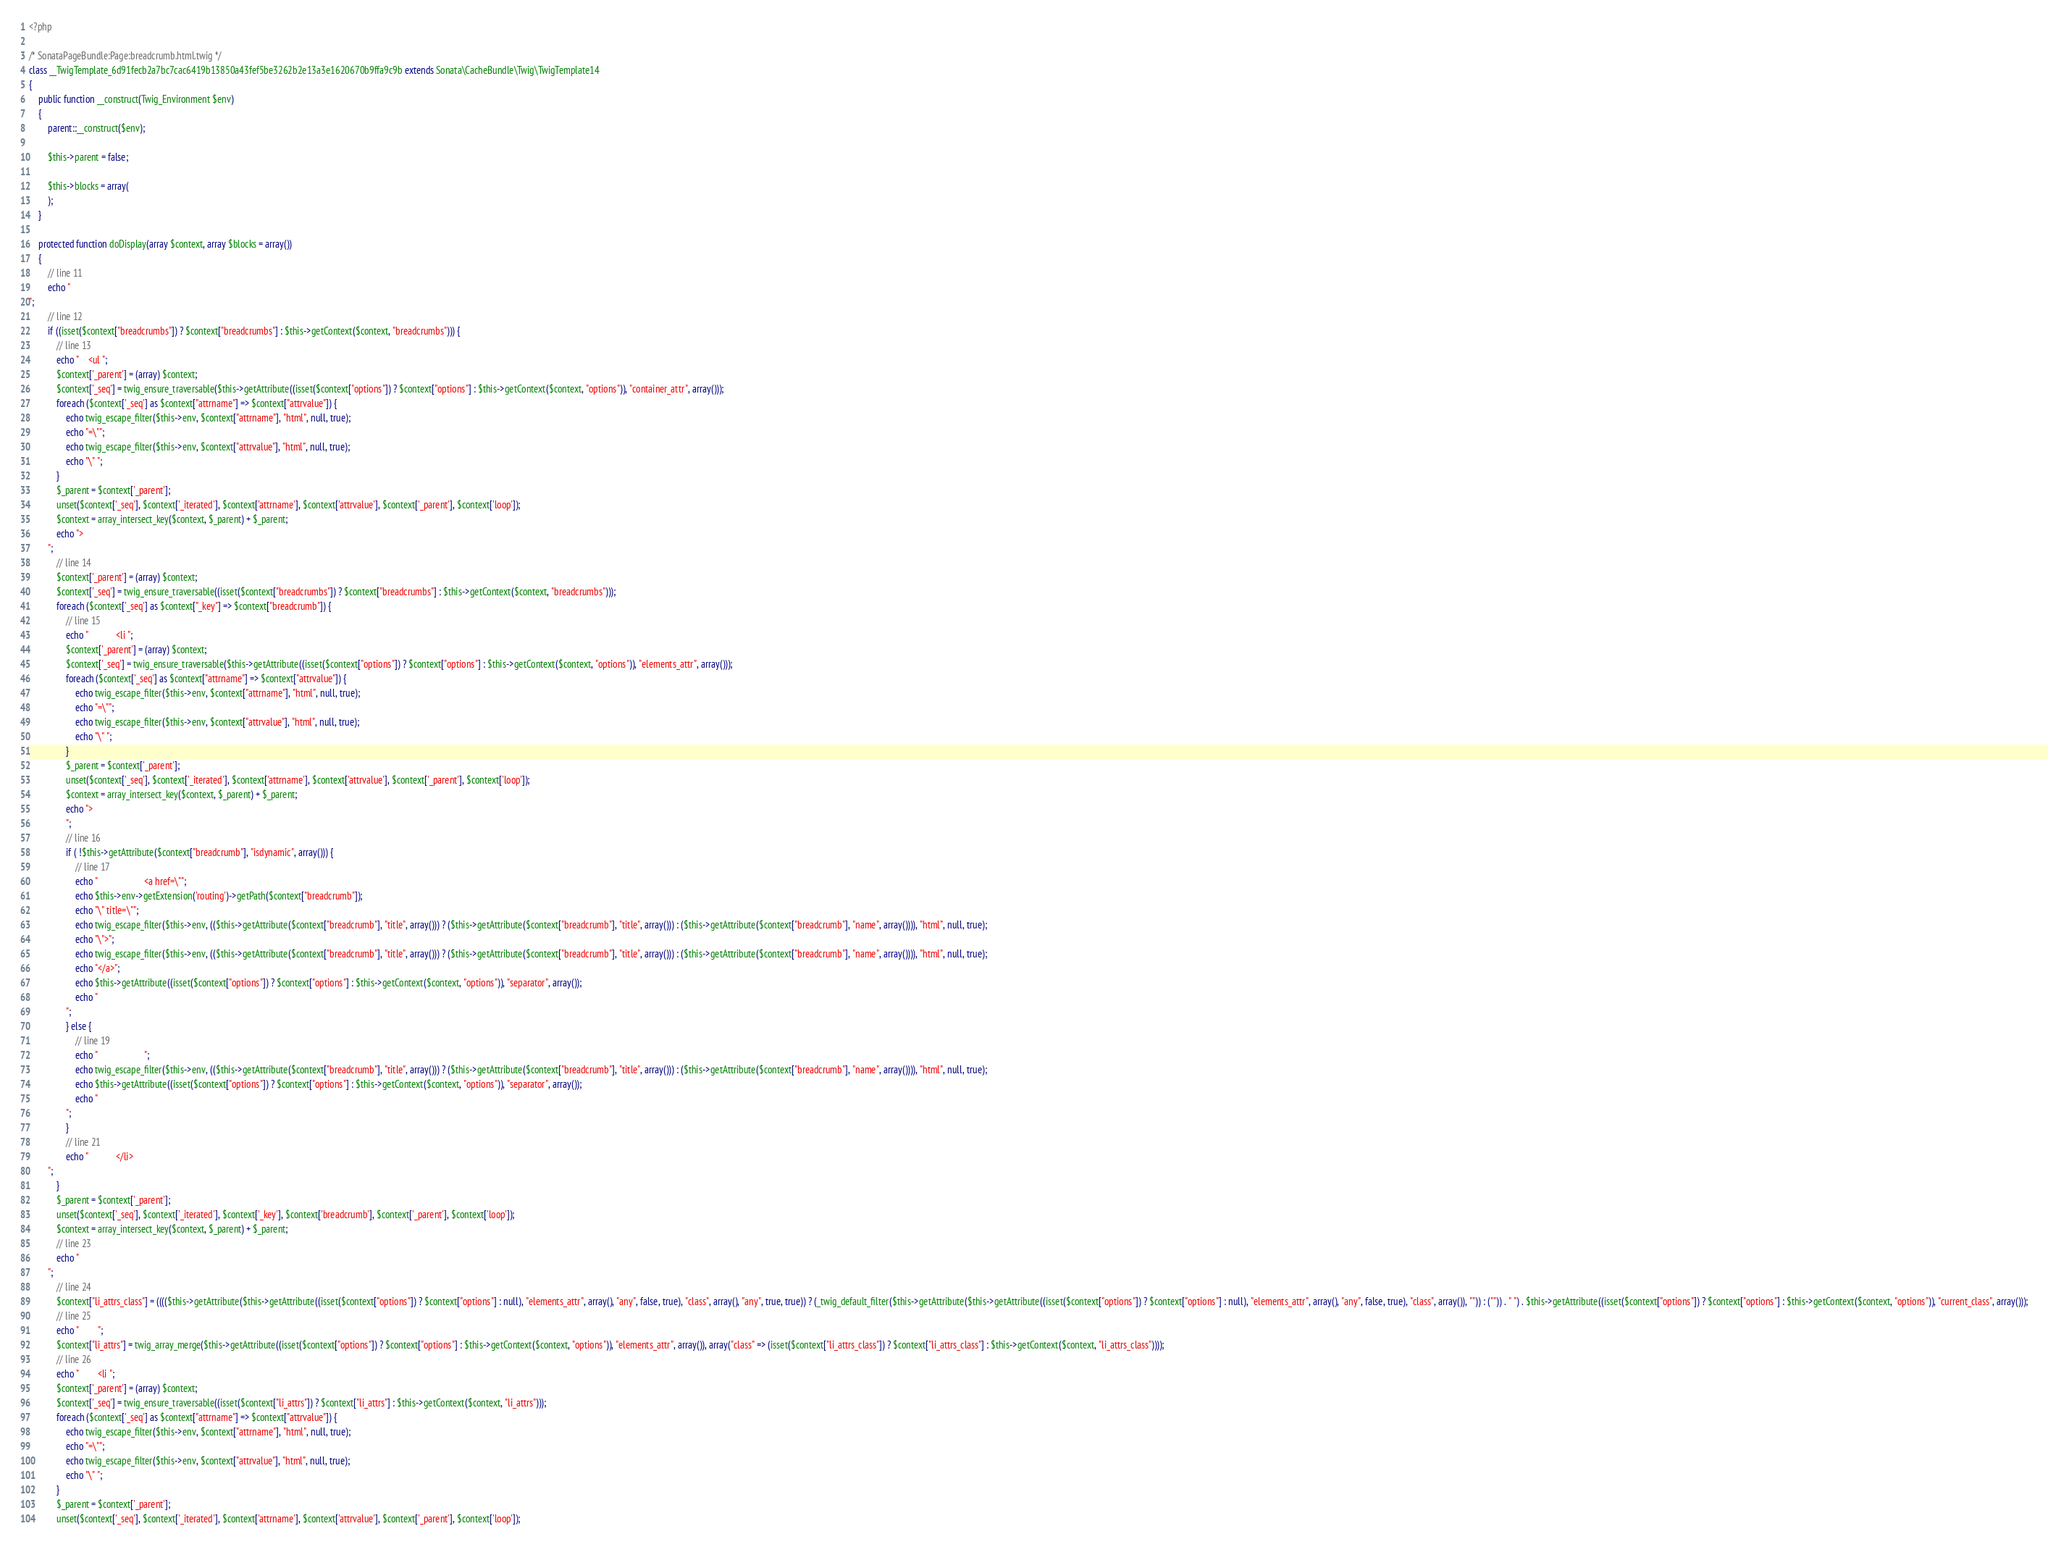Convert code to text. <code><loc_0><loc_0><loc_500><loc_500><_PHP_><?php

/* SonataPageBundle:Page:breadcrumb.html.twig */
class __TwigTemplate_6d91fecb2a7bc7cac6419b13850a43fef5be3262b2e13a3e1620670b9ffa9c9b extends Sonata\CacheBundle\Twig\TwigTemplate14
{
    public function __construct(Twig_Environment $env)
    {
        parent::__construct($env);

        $this->parent = false;

        $this->blocks = array(
        );
    }

    protected function doDisplay(array $context, array $blocks = array())
    {
        // line 11
        echo "
";
        // line 12
        if ((isset($context["breadcrumbs"]) ? $context["breadcrumbs"] : $this->getContext($context, "breadcrumbs"))) {
            // line 13
            echo "    <ul ";
            $context['_parent'] = (array) $context;
            $context['_seq'] = twig_ensure_traversable($this->getAttribute((isset($context["options"]) ? $context["options"] : $this->getContext($context, "options")), "container_attr", array()));
            foreach ($context['_seq'] as $context["attrname"] => $context["attrvalue"]) {
                echo twig_escape_filter($this->env, $context["attrname"], "html", null, true);
                echo "=\"";
                echo twig_escape_filter($this->env, $context["attrvalue"], "html", null, true);
                echo "\" ";
            }
            $_parent = $context['_parent'];
            unset($context['_seq'], $context['_iterated'], $context['attrname'], $context['attrvalue'], $context['_parent'], $context['loop']);
            $context = array_intersect_key($context, $_parent) + $_parent;
            echo ">
        ";
            // line 14
            $context['_parent'] = (array) $context;
            $context['_seq'] = twig_ensure_traversable((isset($context["breadcrumbs"]) ? $context["breadcrumbs"] : $this->getContext($context, "breadcrumbs")));
            foreach ($context['_seq'] as $context["_key"] => $context["breadcrumb"]) {
                // line 15
                echo "            <li ";
                $context['_parent'] = (array) $context;
                $context['_seq'] = twig_ensure_traversable($this->getAttribute((isset($context["options"]) ? $context["options"] : $this->getContext($context, "options")), "elements_attr", array()));
                foreach ($context['_seq'] as $context["attrname"] => $context["attrvalue"]) {
                    echo twig_escape_filter($this->env, $context["attrname"], "html", null, true);
                    echo "=\"";
                    echo twig_escape_filter($this->env, $context["attrvalue"], "html", null, true);
                    echo "\" ";
                }
                $_parent = $context['_parent'];
                unset($context['_seq'], $context['_iterated'], $context['attrname'], $context['attrvalue'], $context['_parent'], $context['loop']);
                $context = array_intersect_key($context, $_parent) + $_parent;
                echo ">
                ";
                // line 16
                if ( !$this->getAttribute($context["breadcrumb"], "isdynamic", array())) {
                    // line 17
                    echo "                    <a href=\"";
                    echo $this->env->getExtension('routing')->getPath($context["breadcrumb"]);
                    echo "\" title=\"";
                    echo twig_escape_filter($this->env, (($this->getAttribute($context["breadcrumb"], "title", array())) ? ($this->getAttribute($context["breadcrumb"], "title", array())) : ($this->getAttribute($context["breadcrumb"], "name", array()))), "html", null, true);
                    echo "\">";
                    echo twig_escape_filter($this->env, (($this->getAttribute($context["breadcrumb"], "title", array())) ? ($this->getAttribute($context["breadcrumb"], "title", array())) : ($this->getAttribute($context["breadcrumb"], "name", array()))), "html", null, true);
                    echo "</a>";
                    echo $this->getAttribute((isset($context["options"]) ? $context["options"] : $this->getContext($context, "options")), "separator", array());
                    echo "
                ";
                } else {
                    // line 19
                    echo "                    ";
                    echo twig_escape_filter($this->env, (($this->getAttribute($context["breadcrumb"], "title", array())) ? ($this->getAttribute($context["breadcrumb"], "title", array())) : ($this->getAttribute($context["breadcrumb"], "name", array()))), "html", null, true);
                    echo $this->getAttribute((isset($context["options"]) ? $context["options"] : $this->getContext($context, "options")), "separator", array());
                    echo "
                ";
                }
                // line 21
                echo "            </li>
        ";
            }
            $_parent = $context['_parent'];
            unset($context['_seq'], $context['_iterated'], $context['_key'], $context['breadcrumb'], $context['_parent'], $context['loop']);
            $context = array_intersect_key($context, $_parent) + $_parent;
            // line 23
            echo "
        ";
            // line 24
            $context["li_attrs_class"] = (((($this->getAttribute($this->getAttribute((isset($context["options"]) ? $context["options"] : null), "elements_attr", array(), "any", false, true), "class", array(), "any", true, true)) ? (_twig_default_filter($this->getAttribute($this->getAttribute((isset($context["options"]) ? $context["options"] : null), "elements_attr", array(), "any", false, true), "class", array()), "")) : ("")) . " ") . $this->getAttribute((isset($context["options"]) ? $context["options"] : $this->getContext($context, "options")), "current_class", array()));
            // line 25
            echo "        ";
            $context["li_attrs"] = twig_array_merge($this->getAttribute((isset($context["options"]) ? $context["options"] : $this->getContext($context, "options")), "elements_attr", array()), array("class" => (isset($context["li_attrs_class"]) ? $context["li_attrs_class"] : $this->getContext($context, "li_attrs_class"))));
            // line 26
            echo "        <li ";
            $context['_parent'] = (array) $context;
            $context['_seq'] = twig_ensure_traversable((isset($context["li_attrs"]) ? $context["li_attrs"] : $this->getContext($context, "li_attrs")));
            foreach ($context['_seq'] as $context["attrname"] => $context["attrvalue"]) {
                echo twig_escape_filter($this->env, $context["attrname"], "html", null, true);
                echo "=\"";
                echo twig_escape_filter($this->env, $context["attrvalue"], "html", null, true);
                echo "\" ";
            }
            $_parent = $context['_parent'];
            unset($context['_seq'], $context['_iterated'], $context['attrname'], $context['attrvalue'], $context['_parent'], $context['loop']);</code> 